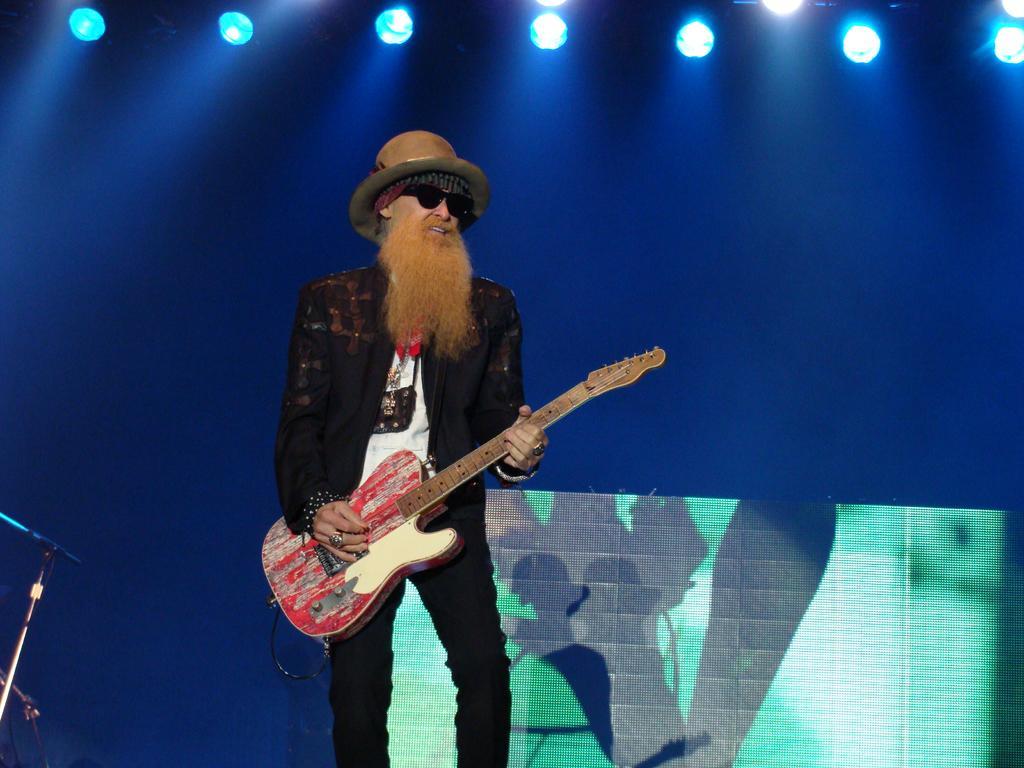How would you summarize this image in a sentence or two? In this image, we can see a human is playing a guitar, he wear a goggles and hat on his head. And left side, we can see some stands and background, there is a screen and lights we can see. 